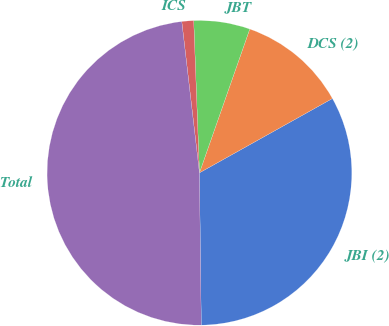Convert chart to OTSL. <chart><loc_0><loc_0><loc_500><loc_500><pie_chart><fcel>JBI (2)<fcel>DCS (2)<fcel>JBT<fcel>ICS<fcel>Total<nl><fcel>32.92%<fcel>11.53%<fcel>5.96%<fcel>1.25%<fcel>48.34%<nl></chart> 